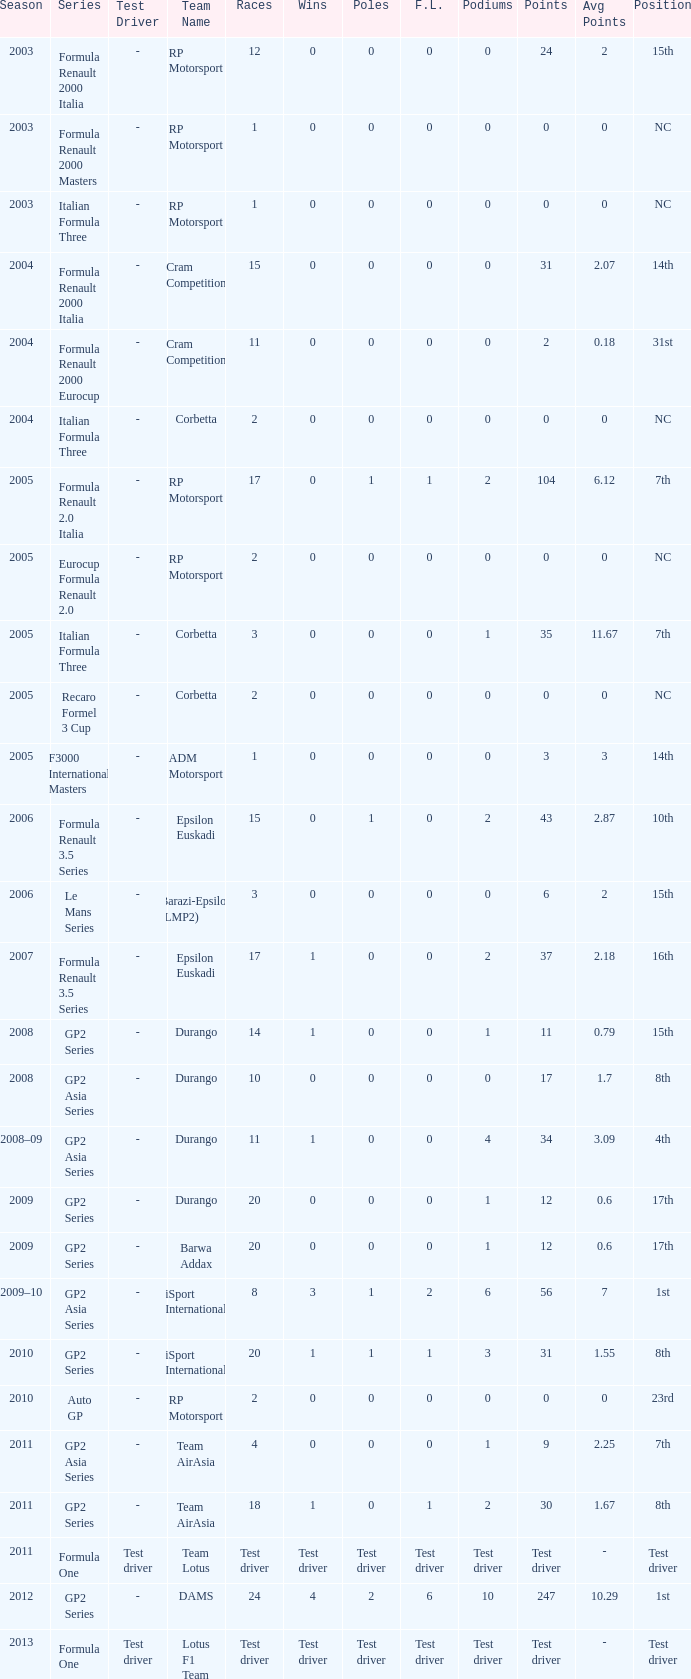What is the number of podiums with 0 wins and 6 points? 0.0. 